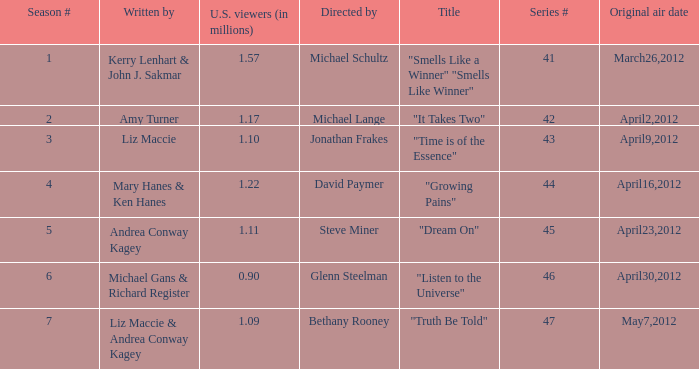What is the title of the episode/s written by Michael Gans & Richard Register? "Listen to the Universe". 